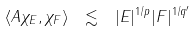<formula> <loc_0><loc_0><loc_500><loc_500>\langle A \chi _ { E } , \chi _ { F } \rangle \ \lesssim \ | E | ^ { 1 / p } | F | ^ { 1 / q ^ { \prime } }</formula> 